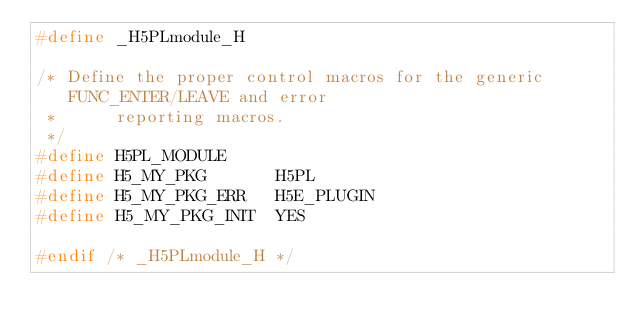<code> <loc_0><loc_0><loc_500><loc_500><_C_>#define _H5PLmodule_H

/* Define the proper control macros for the generic FUNC_ENTER/LEAVE and error
 *      reporting macros.
 */
#define H5PL_MODULE
#define H5_MY_PKG       H5PL
#define H5_MY_PKG_ERR   H5E_PLUGIN
#define H5_MY_PKG_INIT  YES

#endif /* _H5PLmodule_H */


</code> 